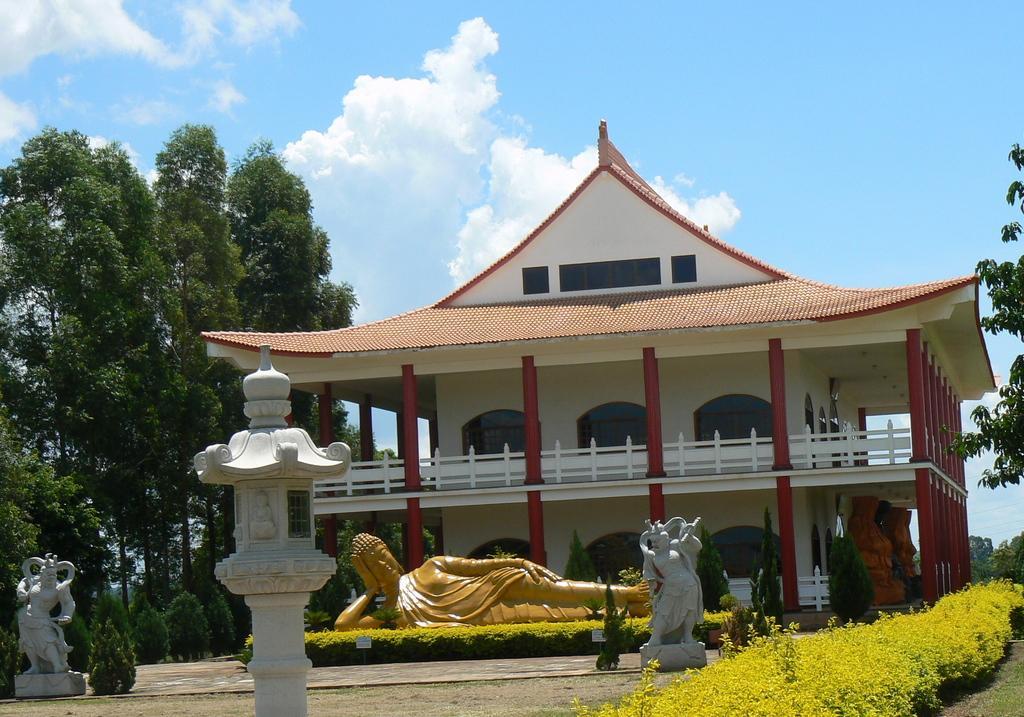Can you describe this image briefly? In this picture I can see few sculptures, number of plants and bushes in front. In the middle of this picture I can see number of trees and a building. In the background I can see the clear sky. 